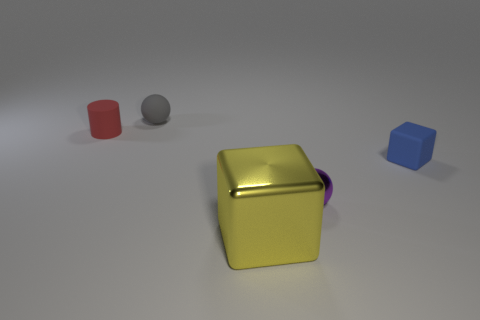What is the material of the gray thing?
Ensure brevity in your answer.  Rubber. There is a thing that is in front of the tiny metallic sphere; what is its shape?
Your answer should be compact. Cube. Are there any purple things that have the same size as the gray ball?
Keep it short and to the point. Yes. Is the material of the sphere in front of the tiny red cylinder the same as the small blue thing?
Offer a terse response. No. Are there an equal number of small things that are right of the purple ball and matte things that are behind the tiny red cylinder?
Give a very brief answer. Yes. The thing that is both in front of the blue object and behind the yellow shiny object has what shape?
Your answer should be compact. Sphere. There is a yellow metal block; what number of rubber balls are to the left of it?
Offer a terse response. 1. How many other things are there of the same shape as the purple object?
Offer a terse response. 1. Are there fewer gray rubber balls than metallic objects?
Your answer should be compact. Yes. What size is the thing that is both to the left of the big yellow cube and on the right side of the rubber cylinder?
Your answer should be compact. Small. 